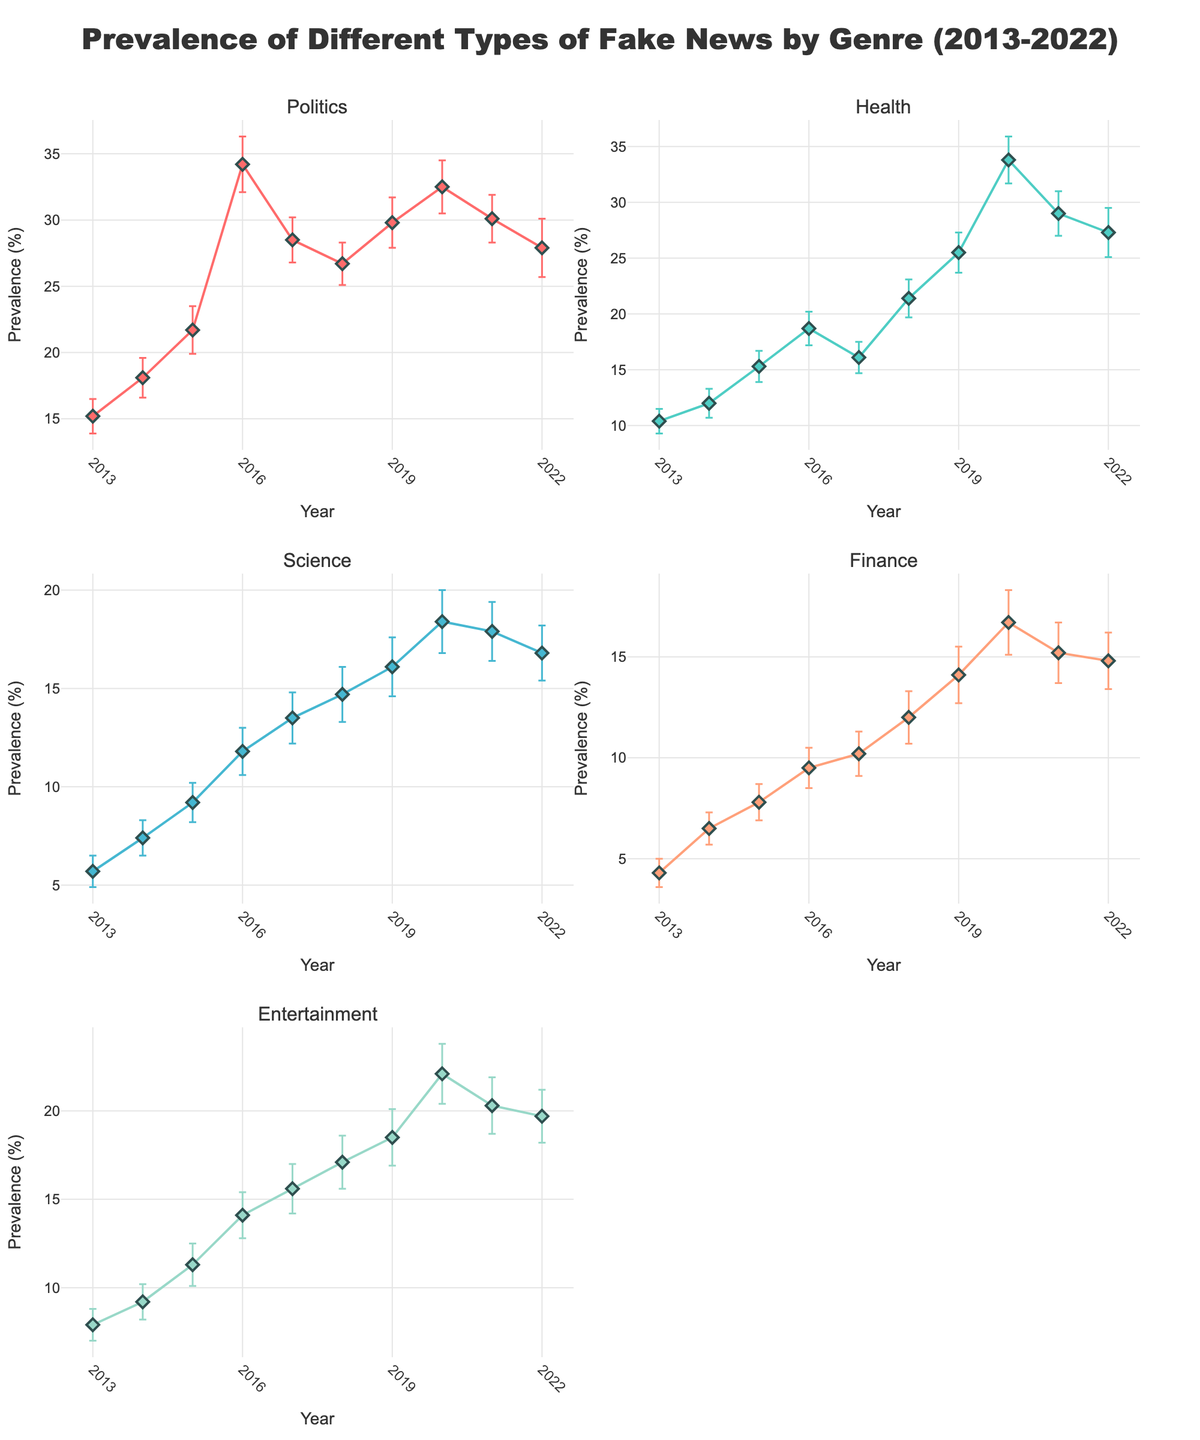What's the overall title of the figure? The title can be found at the top of the figure. It provides a summary of what the data and plots represent.
Answer: Prevalence of Different Types of Fake News by Genre (2013-2022) How does the prevalence of fake news in 'Politics' change from 2013 to 2016? Locate the 'Politics' subplot and track the 'Prevalence' values from 2013 to 2016. Notice the points and connect them visually.
Answer: It increases from 15.2% to 34.2% Which genre shows the highest peak in fake news prevalence in 2020? Look at the values for 2020 in each subplot and compare the peaks.
Answer: Health Between which years did 'Entertainment' show the most significant increase in fake news prevalence? Follow the 'Entertainment' subplot and identify where the largest jump between consecutive years is.
Answer: 2019 to 2020 Which genre had the smallest standard error in 2022? Check the size of the error bars for each genre in the year 2022.
Answer: Science What general trend do you observe for the prevalence of fake news in 'Finance' from 2013 to 2022? Observe and describe the movement of the line for 'Finance' over the years.
Answer: Generally increasing with a slight drop after 2020 Is the prevalence of fake news in 'Science' higher or lower in 2021 compared to 2018? Compare the plot points for the years 2018 and 2021 in the 'Science' subplot.
Answer: Lower in 2021 How do the standard errors for 'Health' compare between 2016 and 2022? Observe the error bars' sizes for 'Health' in both years and compare their lengths.
Answer: Larger in 2022 Which genre has the least variation in fake news prevalence over the years? Look at all subplots and assess which line stays the closest to a horizontal line, implying the least variation.
Answer: Science Did the prevalence of fake news in 'Politics' ever exceed 30%? If so, which years? Check the 'Politics' subplot for any points above the 30% mark and note the corresponding years.
Answer: Yes, in 2016, 2019, and 2020 